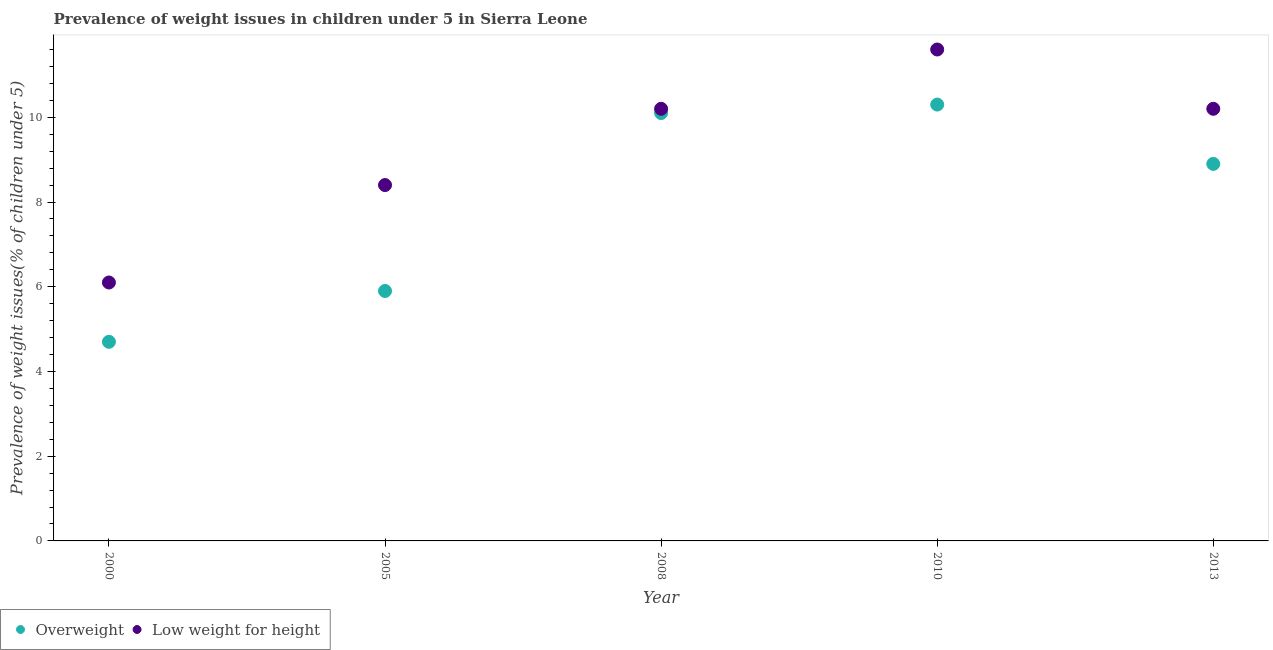Is the number of dotlines equal to the number of legend labels?
Give a very brief answer. Yes. What is the percentage of underweight children in 2013?
Your answer should be very brief. 10.2. Across all years, what is the maximum percentage of underweight children?
Give a very brief answer. 11.6. Across all years, what is the minimum percentage of underweight children?
Ensure brevity in your answer.  6.1. What is the total percentage of overweight children in the graph?
Your answer should be compact. 39.9. What is the difference between the percentage of underweight children in 2008 and that in 2010?
Your answer should be very brief. -1.4. What is the difference between the percentage of overweight children in 2005 and the percentage of underweight children in 2008?
Give a very brief answer. -4.3. What is the average percentage of underweight children per year?
Keep it short and to the point. 9.3. In the year 2008, what is the difference between the percentage of underweight children and percentage of overweight children?
Offer a very short reply. 0.1. In how many years, is the percentage of overweight children greater than 1.2000000000000002 %?
Offer a terse response. 5. What is the ratio of the percentage of underweight children in 2000 to that in 2005?
Offer a very short reply. 0.73. Is the percentage of overweight children in 2000 less than that in 2013?
Your answer should be compact. Yes. What is the difference between the highest and the second highest percentage of underweight children?
Provide a short and direct response. 1.4. What is the difference between the highest and the lowest percentage of overweight children?
Offer a very short reply. 5.6. Does the percentage of overweight children monotonically increase over the years?
Your answer should be very brief. No. Is the percentage of overweight children strictly less than the percentage of underweight children over the years?
Make the answer very short. Yes. How many dotlines are there?
Provide a succinct answer. 2. How many years are there in the graph?
Your answer should be very brief. 5. Are the values on the major ticks of Y-axis written in scientific E-notation?
Offer a terse response. No. Does the graph contain any zero values?
Offer a very short reply. No. Does the graph contain grids?
Your answer should be very brief. No. Where does the legend appear in the graph?
Offer a very short reply. Bottom left. How many legend labels are there?
Offer a terse response. 2. How are the legend labels stacked?
Ensure brevity in your answer.  Horizontal. What is the title of the graph?
Keep it short and to the point. Prevalence of weight issues in children under 5 in Sierra Leone. Does "Forest" appear as one of the legend labels in the graph?
Keep it short and to the point. No. What is the label or title of the Y-axis?
Your response must be concise. Prevalence of weight issues(% of children under 5). What is the Prevalence of weight issues(% of children under 5) in Overweight in 2000?
Offer a very short reply. 4.7. What is the Prevalence of weight issues(% of children under 5) of Low weight for height in 2000?
Provide a short and direct response. 6.1. What is the Prevalence of weight issues(% of children under 5) in Overweight in 2005?
Give a very brief answer. 5.9. What is the Prevalence of weight issues(% of children under 5) of Low weight for height in 2005?
Provide a succinct answer. 8.4. What is the Prevalence of weight issues(% of children under 5) of Overweight in 2008?
Give a very brief answer. 10.1. What is the Prevalence of weight issues(% of children under 5) in Low weight for height in 2008?
Your answer should be very brief. 10.2. What is the Prevalence of weight issues(% of children under 5) of Overweight in 2010?
Provide a succinct answer. 10.3. What is the Prevalence of weight issues(% of children under 5) of Low weight for height in 2010?
Your answer should be very brief. 11.6. What is the Prevalence of weight issues(% of children under 5) in Overweight in 2013?
Make the answer very short. 8.9. What is the Prevalence of weight issues(% of children under 5) of Low weight for height in 2013?
Your answer should be compact. 10.2. Across all years, what is the maximum Prevalence of weight issues(% of children under 5) of Overweight?
Your answer should be compact. 10.3. Across all years, what is the maximum Prevalence of weight issues(% of children under 5) of Low weight for height?
Your response must be concise. 11.6. Across all years, what is the minimum Prevalence of weight issues(% of children under 5) in Overweight?
Your answer should be compact. 4.7. Across all years, what is the minimum Prevalence of weight issues(% of children under 5) of Low weight for height?
Provide a succinct answer. 6.1. What is the total Prevalence of weight issues(% of children under 5) of Overweight in the graph?
Keep it short and to the point. 39.9. What is the total Prevalence of weight issues(% of children under 5) in Low weight for height in the graph?
Your response must be concise. 46.5. What is the difference between the Prevalence of weight issues(% of children under 5) of Overweight in 2000 and that in 2008?
Offer a very short reply. -5.4. What is the difference between the Prevalence of weight issues(% of children under 5) in Low weight for height in 2000 and that in 2008?
Make the answer very short. -4.1. What is the difference between the Prevalence of weight issues(% of children under 5) in Low weight for height in 2000 and that in 2013?
Give a very brief answer. -4.1. What is the difference between the Prevalence of weight issues(% of children under 5) of Overweight in 2005 and that in 2008?
Provide a succinct answer. -4.2. What is the difference between the Prevalence of weight issues(% of children under 5) in Overweight in 2005 and that in 2010?
Keep it short and to the point. -4.4. What is the difference between the Prevalence of weight issues(% of children under 5) of Low weight for height in 2005 and that in 2013?
Offer a terse response. -1.8. What is the difference between the Prevalence of weight issues(% of children under 5) of Overweight in 2008 and that in 2010?
Your answer should be very brief. -0.2. What is the difference between the Prevalence of weight issues(% of children under 5) in Low weight for height in 2008 and that in 2010?
Provide a succinct answer. -1.4. What is the difference between the Prevalence of weight issues(% of children under 5) of Overweight in 2008 and that in 2013?
Your answer should be very brief. 1.2. What is the difference between the Prevalence of weight issues(% of children under 5) in Low weight for height in 2010 and that in 2013?
Make the answer very short. 1.4. What is the difference between the Prevalence of weight issues(% of children under 5) in Overweight in 2000 and the Prevalence of weight issues(% of children under 5) in Low weight for height in 2008?
Your answer should be very brief. -5.5. What is the difference between the Prevalence of weight issues(% of children under 5) of Overweight in 2000 and the Prevalence of weight issues(% of children under 5) of Low weight for height in 2010?
Provide a succinct answer. -6.9. What is the difference between the Prevalence of weight issues(% of children under 5) in Overweight in 2000 and the Prevalence of weight issues(% of children under 5) in Low weight for height in 2013?
Give a very brief answer. -5.5. What is the difference between the Prevalence of weight issues(% of children under 5) in Overweight in 2005 and the Prevalence of weight issues(% of children under 5) in Low weight for height in 2013?
Make the answer very short. -4.3. What is the difference between the Prevalence of weight issues(% of children under 5) in Overweight in 2010 and the Prevalence of weight issues(% of children under 5) in Low weight for height in 2013?
Give a very brief answer. 0.1. What is the average Prevalence of weight issues(% of children under 5) in Overweight per year?
Your answer should be very brief. 7.98. What is the average Prevalence of weight issues(% of children under 5) of Low weight for height per year?
Your response must be concise. 9.3. In the year 2005, what is the difference between the Prevalence of weight issues(% of children under 5) of Overweight and Prevalence of weight issues(% of children under 5) of Low weight for height?
Ensure brevity in your answer.  -2.5. What is the ratio of the Prevalence of weight issues(% of children under 5) of Overweight in 2000 to that in 2005?
Provide a succinct answer. 0.8. What is the ratio of the Prevalence of weight issues(% of children under 5) of Low weight for height in 2000 to that in 2005?
Your response must be concise. 0.73. What is the ratio of the Prevalence of weight issues(% of children under 5) of Overweight in 2000 to that in 2008?
Give a very brief answer. 0.47. What is the ratio of the Prevalence of weight issues(% of children under 5) in Low weight for height in 2000 to that in 2008?
Give a very brief answer. 0.6. What is the ratio of the Prevalence of weight issues(% of children under 5) of Overweight in 2000 to that in 2010?
Your response must be concise. 0.46. What is the ratio of the Prevalence of weight issues(% of children under 5) of Low weight for height in 2000 to that in 2010?
Provide a succinct answer. 0.53. What is the ratio of the Prevalence of weight issues(% of children under 5) of Overweight in 2000 to that in 2013?
Offer a terse response. 0.53. What is the ratio of the Prevalence of weight issues(% of children under 5) of Low weight for height in 2000 to that in 2013?
Provide a succinct answer. 0.6. What is the ratio of the Prevalence of weight issues(% of children under 5) of Overweight in 2005 to that in 2008?
Your answer should be compact. 0.58. What is the ratio of the Prevalence of weight issues(% of children under 5) in Low weight for height in 2005 to that in 2008?
Provide a succinct answer. 0.82. What is the ratio of the Prevalence of weight issues(% of children under 5) of Overweight in 2005 to that in 2010?
Ensure brevity in your answer.  0.57. What is the ratio of the Prevalence of weight issues(% of children under 5) of Low weight for height in 2005 to that in 2010?
Keep it short and to the point. 0.72. What is the ratio of the Prevalence of weight issues(% of children under 5) of Overweight in 2005 to that in 2013?
Provide a short and direct response. 0.66. What is the ratio of the Prevalence of weight issues(% of children under 5) in Low weight for height in 2005 to that in 2013?
Keep it short and to the point. 0.82. What is the ratio of the Prevalence of weight issues(% of children under 5) of Overweight in 2008 to that in 2010?
Provide a succinct answer. 0.98. What is the ratio of the Prevalence of weight issues(% of children under 5) of Low weight for height in 2008 to that in 2010?
Your answer should be compact. 0.88. What is the ratio of the Prevalence of weight issues(% of children under 5) in Overweight in 2008 to that in 2013?
Provide a short and direct response. 1.13. What is the ratio of the Prevalence of weight issues(% of children under 5) in Overweight in 2010 to that in 2013?
Keep it short and to the point. 1.16. What is the ratio of the Prevalence of weight issues(% of children under 5) of Low weight for height in 2010 to that in 2013?
Offer a terse response. 1.14. What is the difference between the highest and the second highest Prevalence of weight issues(% of children under 5) in Low weight for height?
Ensure brevity in your answer.  1.4. 